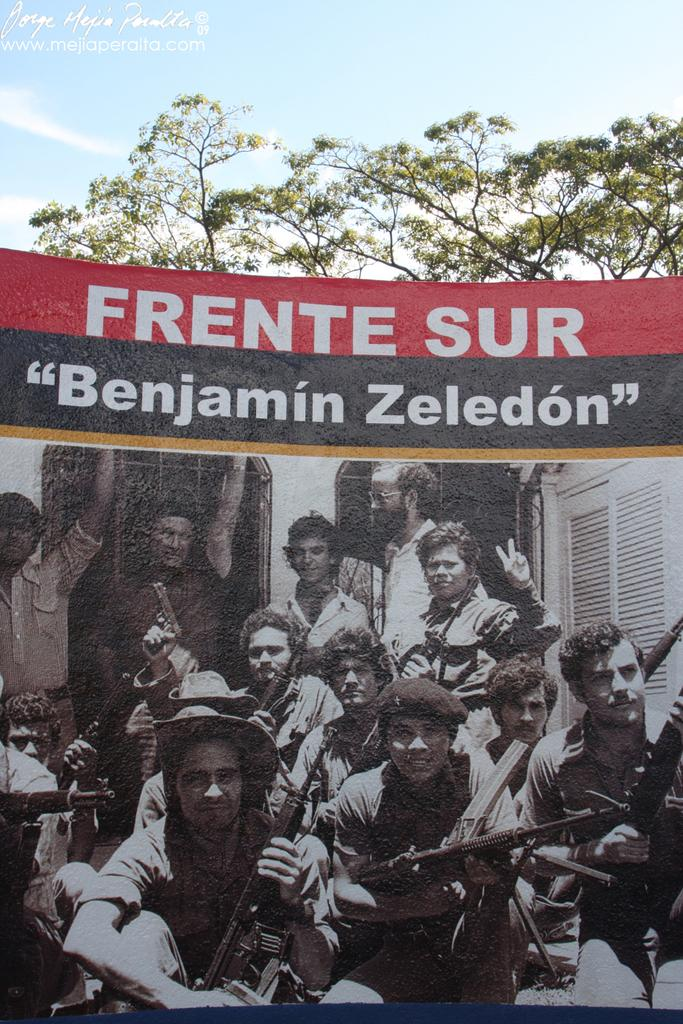What is featured on the poster in the image? The poster has a picture of a group of people. Is there any text on the poster? Yes, there is text on the poster. What can be seen in the background of the image? Trees and the sky are visible in the image. How would you describe the sky in the image? The sky appears to be cloudy in the image. Can you see a sweater hanging on the tree in the image? There is no sweater hanging on the tree in the image. Is there a bell ringing in the background of the image? There is no bell ringing in the background of the image. 